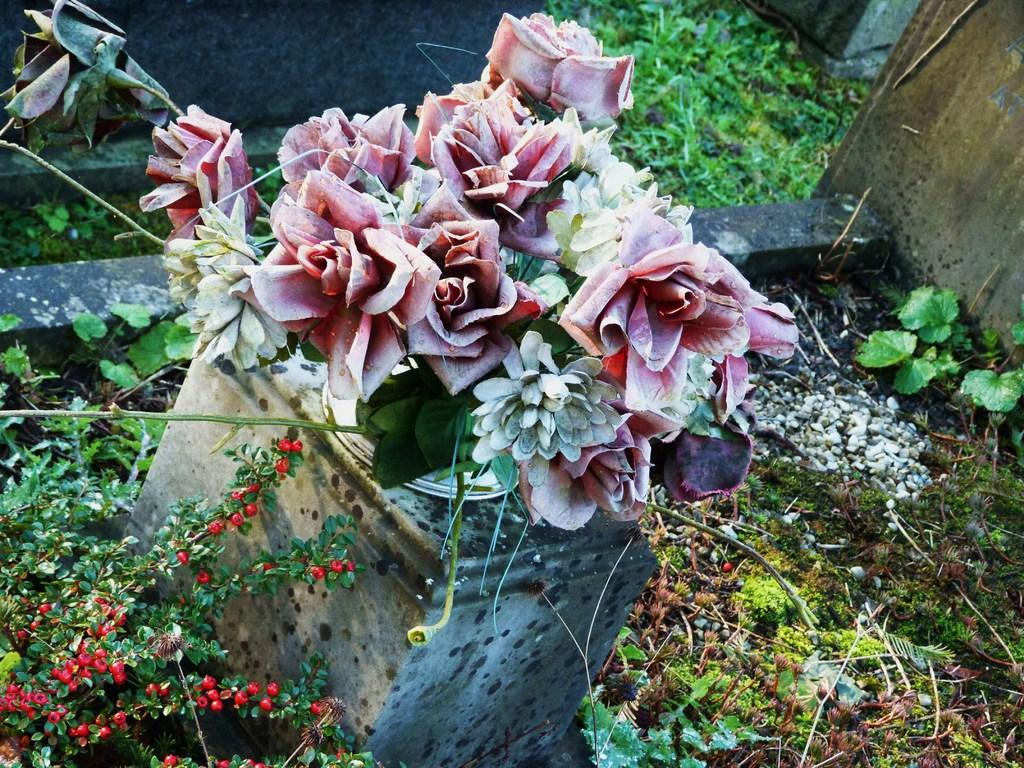What type of plants can be seen in the image? There are green color plants in the image. What type of slip can be seen on the plants in the image? There is no slip present on the plants in the image; they are simply green color plants. 